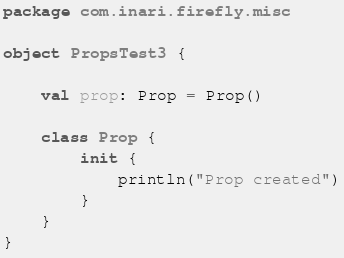Convert code to text. <code><loc_0><loc_0><loc_500><loc_500><_Kotlin_>package com.inari.firefly.misc

object PropsTest3 {

    val prop: Prop = Prop()

    class Prop {
        init {
            println("Prop created")
        }
    }
}</code> 